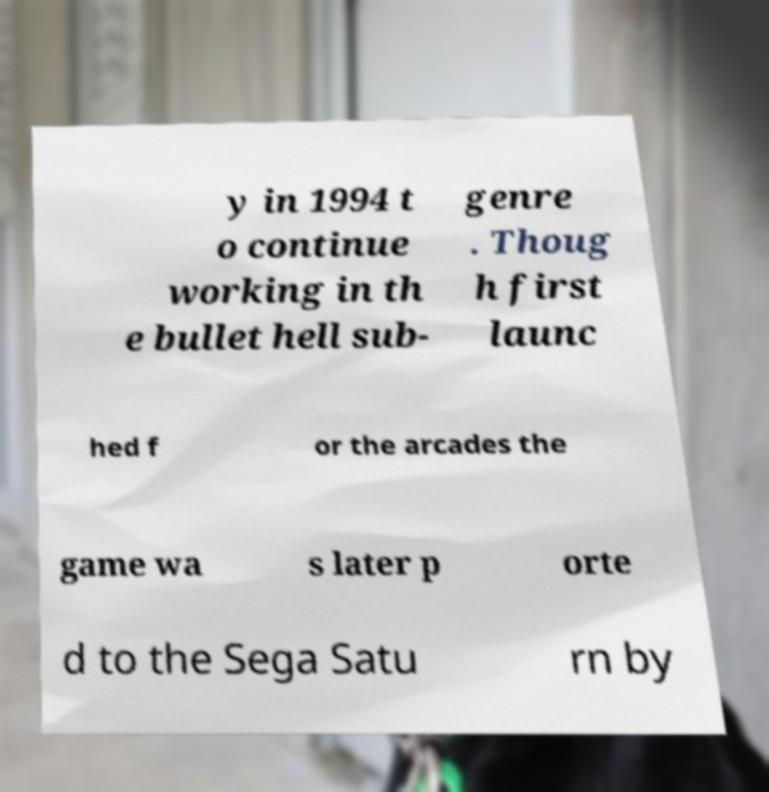I need the written content from this picture converted into text. Can you do that? y in 1994 t o continue working in th e bullet hell sub- genre . Thoug h first launc hed f or the arcades the game wa s later p orte d to the Sega Satu rn by 